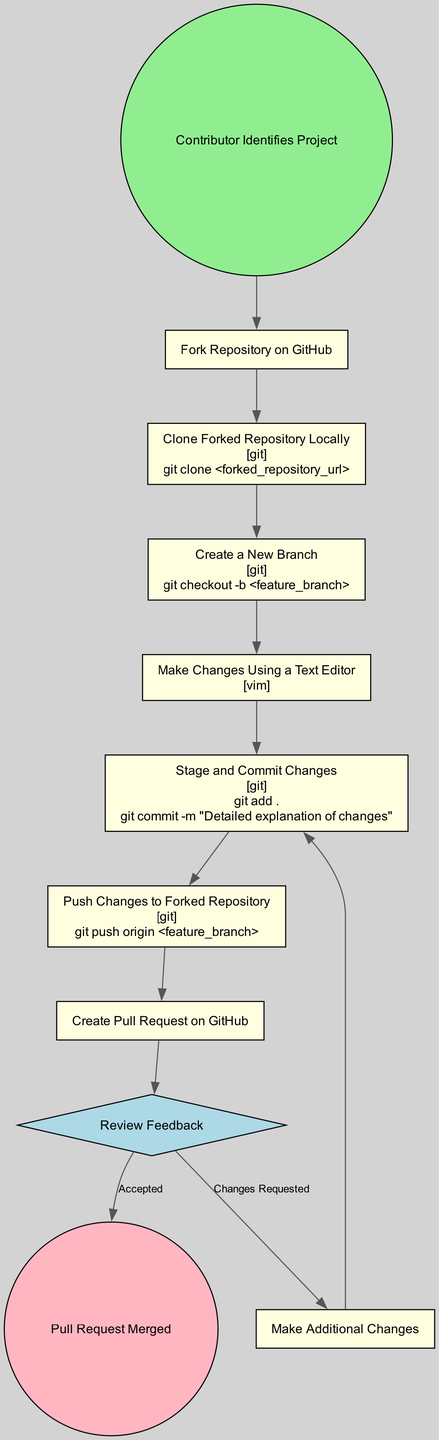What is the first step in the open-source contribution process? The first step is that the contributor identifies a project they wish to contribute to. This is derived from the initial node labeled "Contributor Identifies Project."
Answer: Contributor Identifies Project How many actions are there in the diagram? To find the total number of actions, we can count the elements labeled as "Action" in the diagram. There are six actions indicated: Fork Repository, Clone Forked Repository, Create a New Branch, Make Changes, Stage and Commit Changes, and Push Changes. Therefore, the total is six.
Answer: Six What tool is used for staging and committing changes? The tool mentioned for staging and committing changes is Git. This is specified in the node labeled "Stage and Commit Changes" which mentions Git as its tool.
Answer: Git What happens if changes are requested during the review feedback? If changes are requested, the flow indicates that the contributor must make additional changes and then return to stage and commit those changes again. This can be traced through the decision node "Review Feedback" leading to the action node "Make Additional Changes."
Answer: Make Additional Changes Which action follows the "Push Changes to Forked Repository"? The action that follows "Push Changes to Forked Repository" is "Create Pull Request on GitHub." This can be seen as a direct progression from the corresponding node for pushing changes to the pull request node.
Answer: Create Pull Request on GitHub What is the consequence of a pull request being accepted? When a pull request is accepted, the process culminates in the final step, which is labeled "Pull Request Merged." This is the terminal action as indicated by the end event in the diagram.
Answer: Pull Request Merged If a contributor pushes changes to the wrong branch, where do they go next? If a contributor pushes changes to the wrong branch, they would typically need to revert or fix the changes, which might lead to additional commits or even creating a new branch. However, this specific sequence isn't directly covered in the current diagram; therefore, the next step may vary but typically should refer back to review or adjust changes.
Answer: Varies by specific scenario What shape represents the decision nodes in this diagram? The decision nodes in the diagram are represented by a diamond shape, as can be identified from the node labeled "Review Feedback." This is a conventional representation in activity diagrams for decision-making points.
Answer: Diamond 